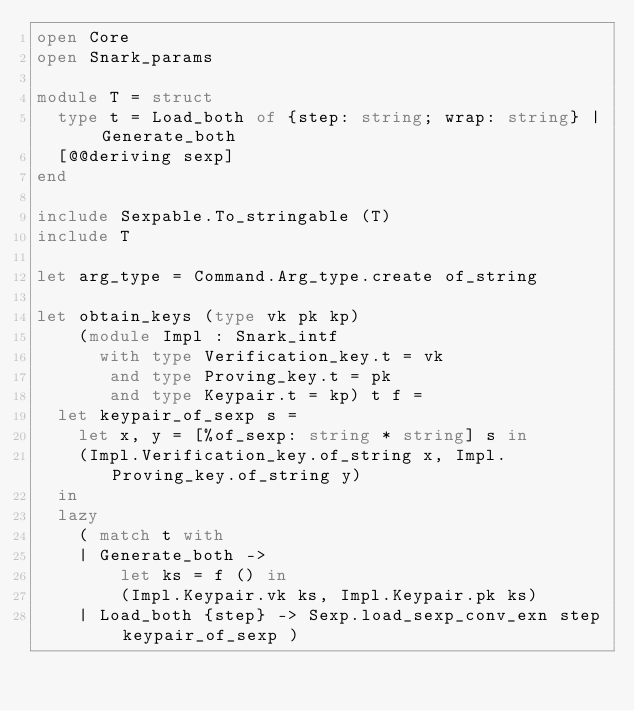Convert code to text. <code><loc_0><loc_0><loc_500><loc_500><_OCaml_>open Core
open Snark_params

module T = struct
  type t = Load_both of {step: string; wrap: string} | Generate_both
  [@@deriving sexp]
end

include Sexpable.To_stringable (T)
include T

let arg_type = Command.Arg_type.create of_string

let obtain_keys (type vk pk kp)
    (module Impl : Snark_intf
      with type Verification_key.t = vk
       and type Proving_key.t = pk
       and type Keypair.t = kp) t f =
  let keypair_of_sexp s =
    let x, y = [%of_sexp: string * string] s in
    (Impl.Verification_key.of_string x, Impl.Proving_key.of_string y)
  in
  lazy
    ( match t with
    | Generate_both ->
        let ks = f () in
        (Impl.Keypair.vk ks, Impl.Keypair.pk ks)
    | Load_both {step} -> Sexp.load_sexp_conv_exn step keypair_of_sexp )
</code> 